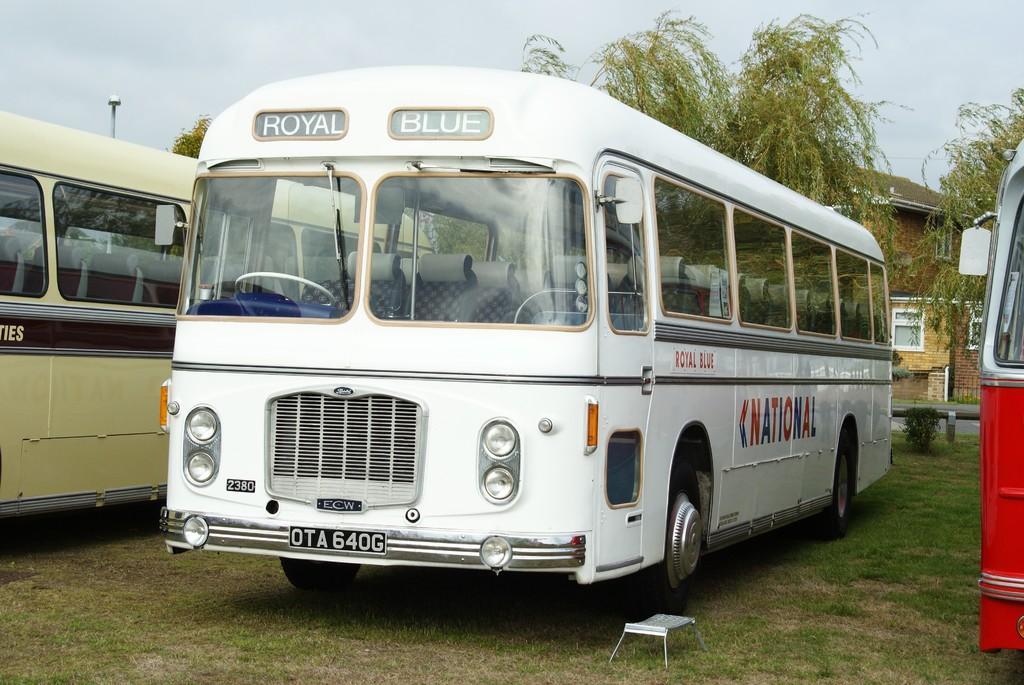Can you describe this image briefly? In this image we can see three vehicles which are in different colors and we can see some text on the vehicles and there is a stool. We can see some trees and a building in the background and at the top we can see the sky. 